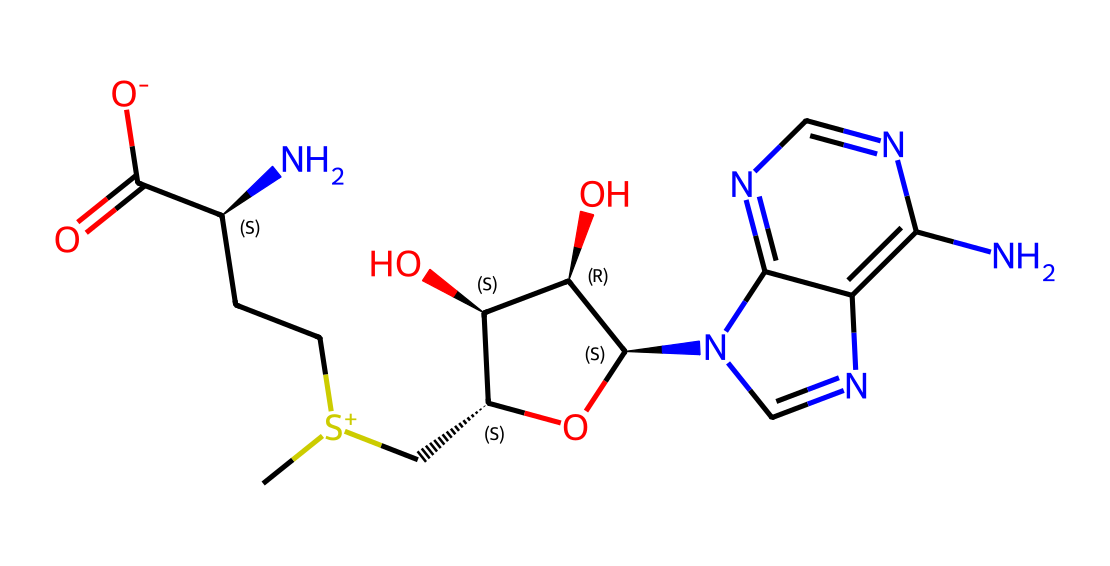What is the total number of carbon atoms in S-adenosylmethionine? Count the number of "C" present in the SMILES representation. There are 14 carbon atoms in total.
Answer: 14 How many nitrogen atoms are present in the structure of S-adenosylmethionine? Identify the "N" symbols in the SMILES representation. There are 5 nitrogen atoms in the structure.
Answer: 5 What functional group is present in S-adenosylmethionine indicated by the "C(=O)[O-]" part? The "C(=O)[O-]" indicates a carboxylate group (a carboxylic acid deprotonated). This means the compound has a carboxylic acid functional group.
Answer: carboxylate How many chiral centers are in S-adenosylmethionine? Examine the "C@" symbols in the SMILES. Each "C@" indicates a chiral center. There are 4 chirality centers in the molecule.
Answer: 4 What is the stereochemistry at the second chiral center in S-adenosylmethionine? Looking at the "C[C@H](N)" portion of the SMILES, the "C@" indicates it is the S configuration, indicating specific 3D orientation of the substituents.
Answer: S Is S-adenosylmethionine acidic or basic? The presence of a nitrogen with a positive charge and the amino group often indicates basicity, while its carboxylate group contributes acidity. Overall, it exhibits properties of both. However, it's primarily considered basic due to the nitrogen.
Answer: basic What type of compound is S-adenosylmethionine categorized as? Given the presence of chiral centers, functional groups, and its complex structure, S-adenosylmethionine is classified as a naturally occurring amino acid derivative.
Answer: amino acid derivative 